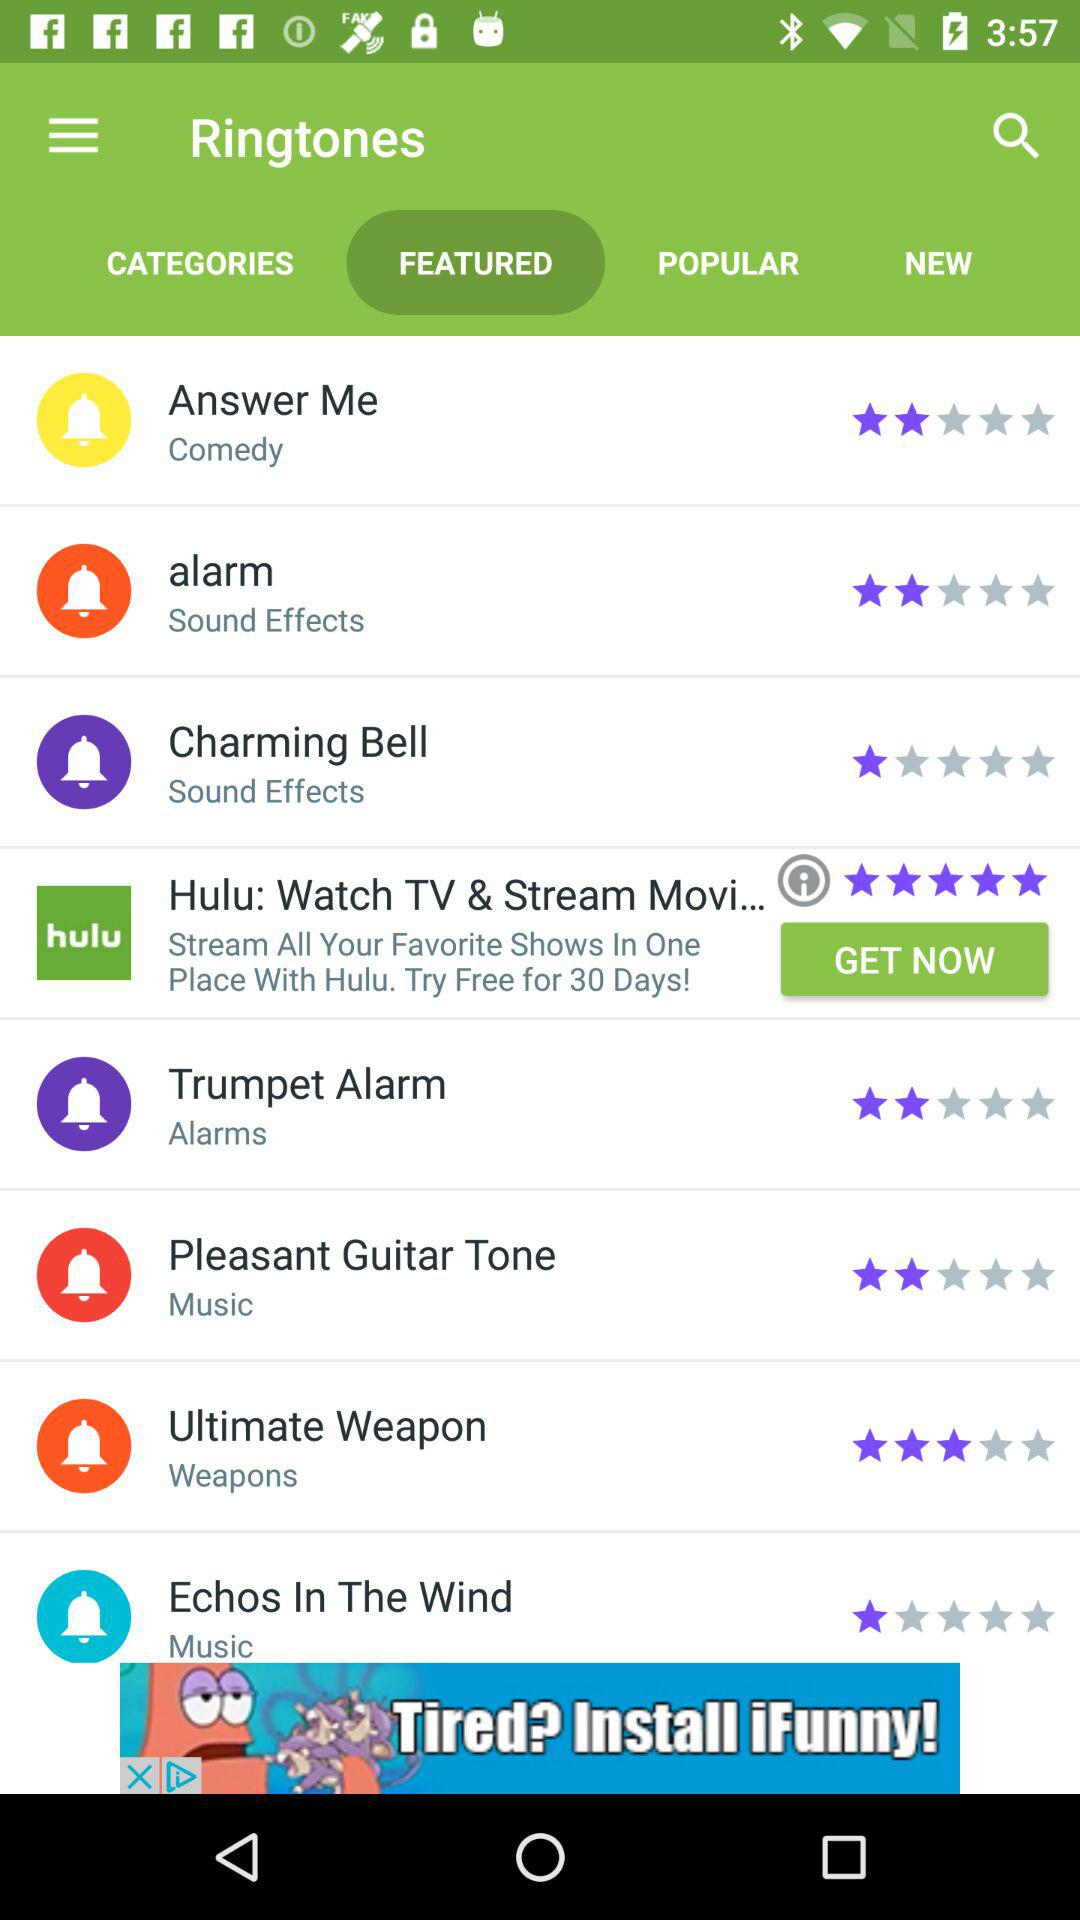What is the rating of the "Trumpet Alarm"? The rating of the "Trumpet Alarm" is 2 stars. 